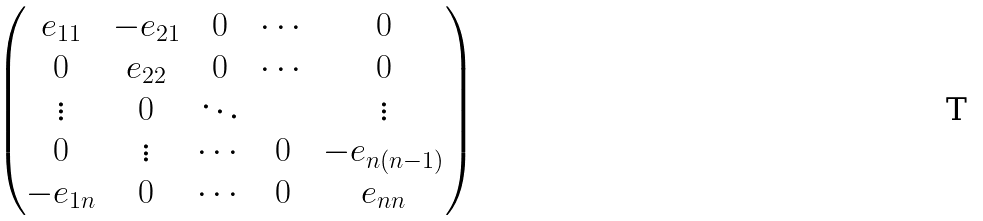<formula> <loc_0><loc_0><loc_500><loc_500>\begin{pmatrix} e _ { 1 1 } & - e _ { 2 1 } & 0 & \cdots & 0 \\ 0 & e _ { 2 2 } & 0 & \cdots & 0 \\ \vdots & 0 & \ddots & & \vdots \\ 0 & \vdots & \cdots & 0 & - e _ { n ( n - 1 ) } \\ - e _ { 1 n } & 0 & \cdots & 0 & e _ { n n } \end{pmatrix}</formula> 